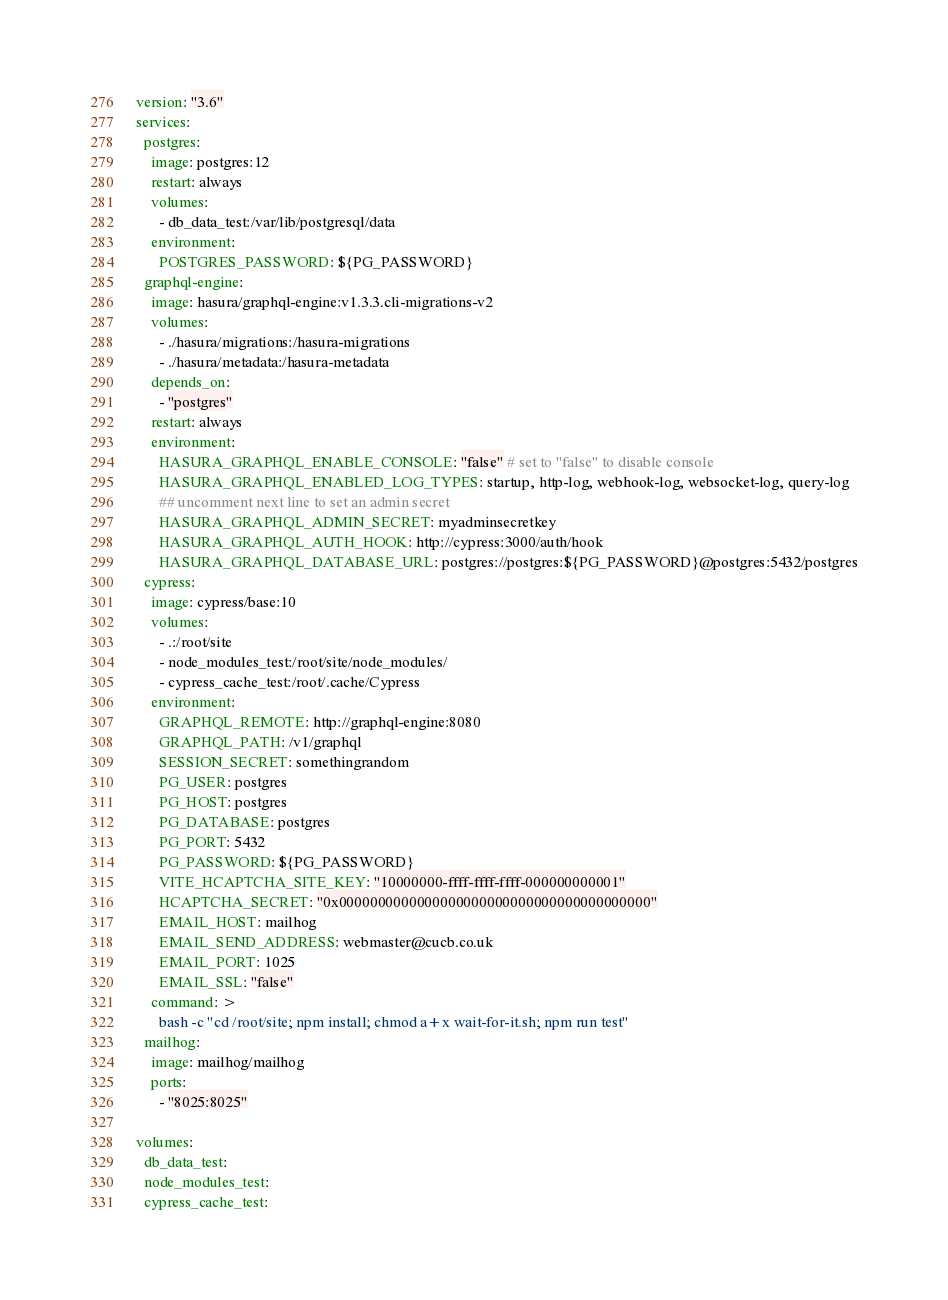Convert code to text. <code><loc_0><loc_0><loc_500><loc_500><_YAML_>version: "3.6"
services:
  postgres:
    image: postgres:12
    restart: always
    volumes:
      - db_data_test:/var/lib/postgresql/data
    environment:
      POSTGRES_PASSWORD: ${PG_PASSWORD}
  graphql-engine:
    image: hasura/graphql-engine:v1.3.3.cli-migrations-v2
    volumes:
      - ./hasura/migrations:/hasura-migrations
      - ./hasura/metadata:/hasura-metadata
    depends_on:
      - "postgres"
    restart: always
    environment:
      HASURA_GRAPHQL_ENABLE_CONSOLE: "false" # set to "false" to disable console
      HASURA_GRAPHQL_ENABLED_LOG_TYPES: startup, http-log, webhook-log, websocket-log, query-log
      ## uncomment next line to set an admin secret
      HASURA_GRAPHQL_ADMIN_SECRET: myadminsecretkey
      HASURA_GRAPHQL_AUTH_HOOK: http://cypress:3000/auth/hook
      HASURA_GRAPHQL_DATABASE_URL: postgres://postgres:${PG_PASSWORD}@postgres:5432/postgres
  cypress:
    image: cypress/base:10
    volumes:
      - .:/root/site
      - node_modules_test:/root/site/node_modules/
      - cypress_cache_test:/root/.cache/Cypress
    environment:
      GRAPHQL_REMOTE: http://graphql-engine:8080
      GRAPHQL_PATH: /v1/graphql
      SESSION_SECRET: somethingrandom
      PG_USER: postgres
      PG_HOST: postgres
      PG_DATABASE: postgres
      PG_PORT: 5432
      PG_PASSWORD: ${PG_PASSWORD}
      VITE_HCAPTCHA_SITE_KEY: "10000000-ffff-ffff-ffff-000000000001"
      HCAPTCHA_SECRET: "0x0000000000000000000000000000000000000000"
      EMAIL_HOST: mailhog
      EMAIL_SEND_ADDRESS: webmaster@cucb.co.uk
      EMAIL_PORT: 1025
      EMAIL_SSL: "false"
    command: >
      bash -c "cd /root/site; npm install; chmod a+x wait-for-it.sh; npm run test"
  mailhog:
    image: mailhog/mailhog
    ports:
      - "8025:8025"

volumes:
  db_data_test:
  node_modules_test:
  cypress_cache_test:
</code> 